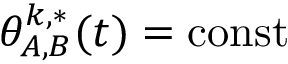Convert formula to latex. <formula><loc_0><loc_0><loc_500><loc_500>\theta _ { A , B } ^ { k , * } ( t ) = c o n s t</formula> 